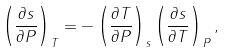<formula> <loc_0><loc_0><loc_500><loc_500>\left ( \frac { \partial s } { \partial P } \right ) _ { T } = - \left ( \frac { \partial T } { \partial P } \right ) _ { s } \left ( \frac { \partial s } { \partial T } \right ) _ { P } ,</formula> 